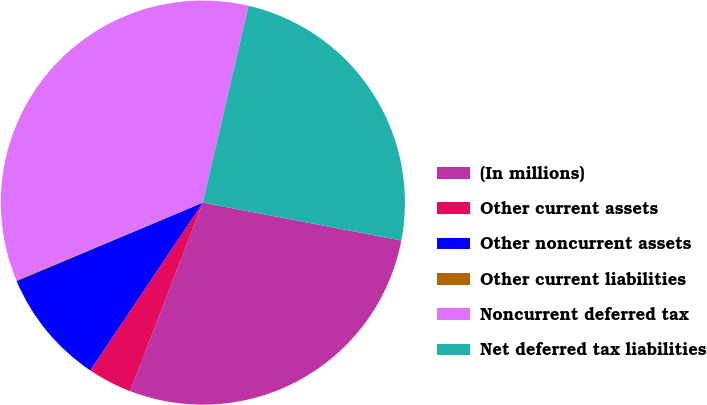<chart> <loc_0><loc_0><loc_500><loc_500><pie_chart><fcel>(In millions)<fcel>Other current assets<fcel>Other noncurrent assets<fcel>Other current liabilities<fcel>Noncurrent deferred tax<fcel>Net deferred tax liabilities<nl><fcel>27.85%<fcel>3.55%<fcel>9.25%<fcel>0.07%<fcel>34.91%<fcel>24.37%<nl></chart> 